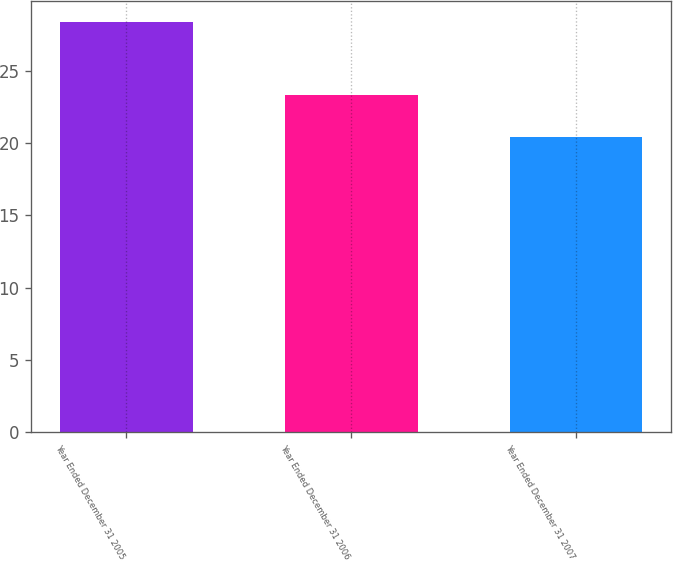Convert chart. <chart><loc_0><loc_0><loc_500><loc_500><bar_chart><fcel>Year Ended December 31 2005<fcel>Year Ended December 31 2006<fcel>Year Ended December 31 2007<nl><fcel>28.4<fcel>23.3<fcel>20.4<nl></chart> 